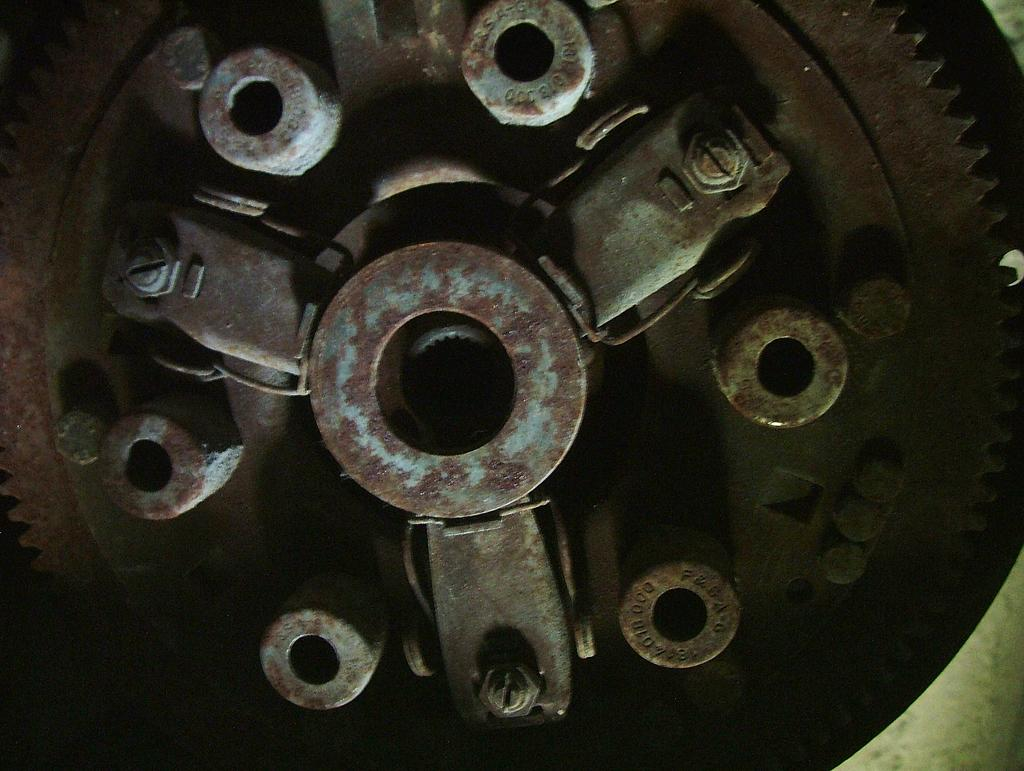What type of object is the main subject of the image? There is a metal spike wheel in the image. What type of club can be seen in the image? There is no club present in the image; it features a metal spike wheel. What type of voice can be heard coming from the metal spike wheel in the image? There is no voice associated with the metal spike wheel in the image, as it is an inanimate object. 